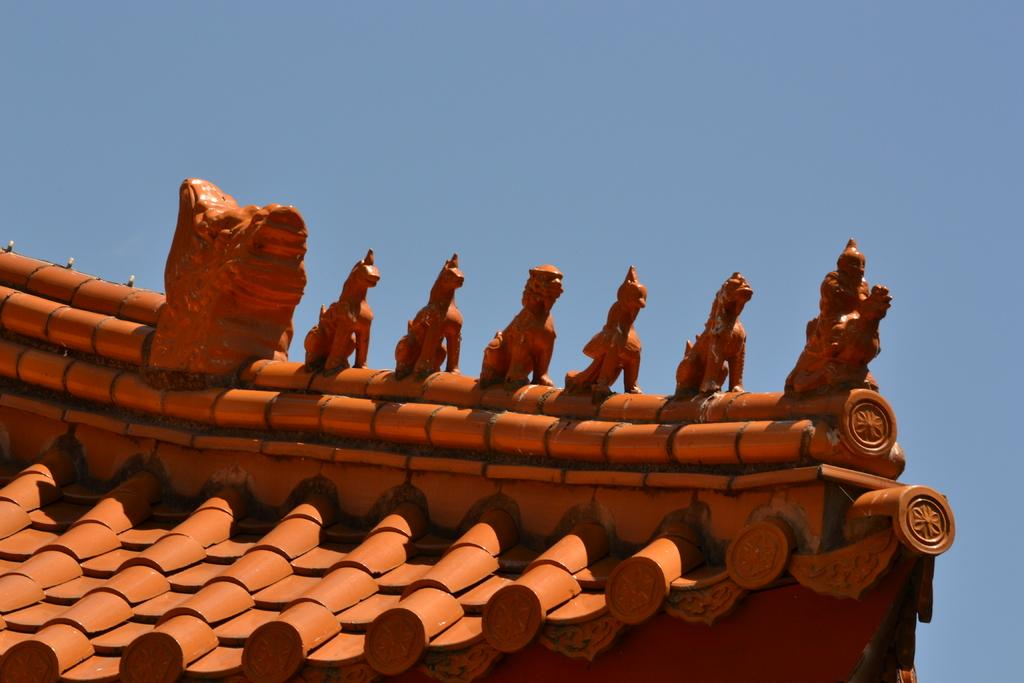What type of structures can be seen on the top of the clay roof in the image? The structures on the top of the clay roof in the image are not specified, but they are visible. What type of songs can be heard being sung by the animals on the farm in the image? There is no farm or animals present in the image, and therefore no songs can be heard. What type of eggnog is being served at the holiday party in the image? There is no holiday party or eggnog present in the image. 